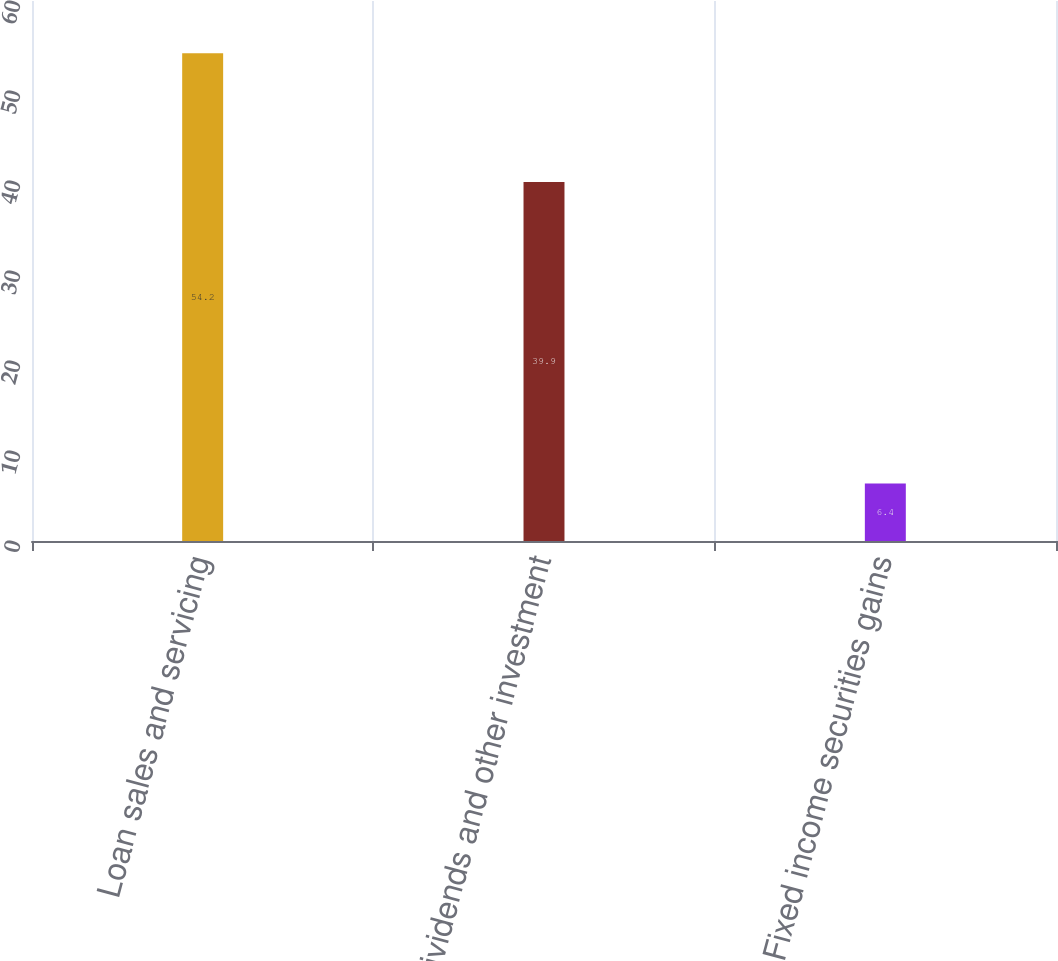<chart> <loc_0><loc_0><loc_500><loc_500><bar_chart><fcel>Loan sales and servicing<fcel>Dividends and other investment<fcel>Fixed income securities gains<nl><fcel>54.2<fcel>39.9<fcel>6.4<nl></chart> 